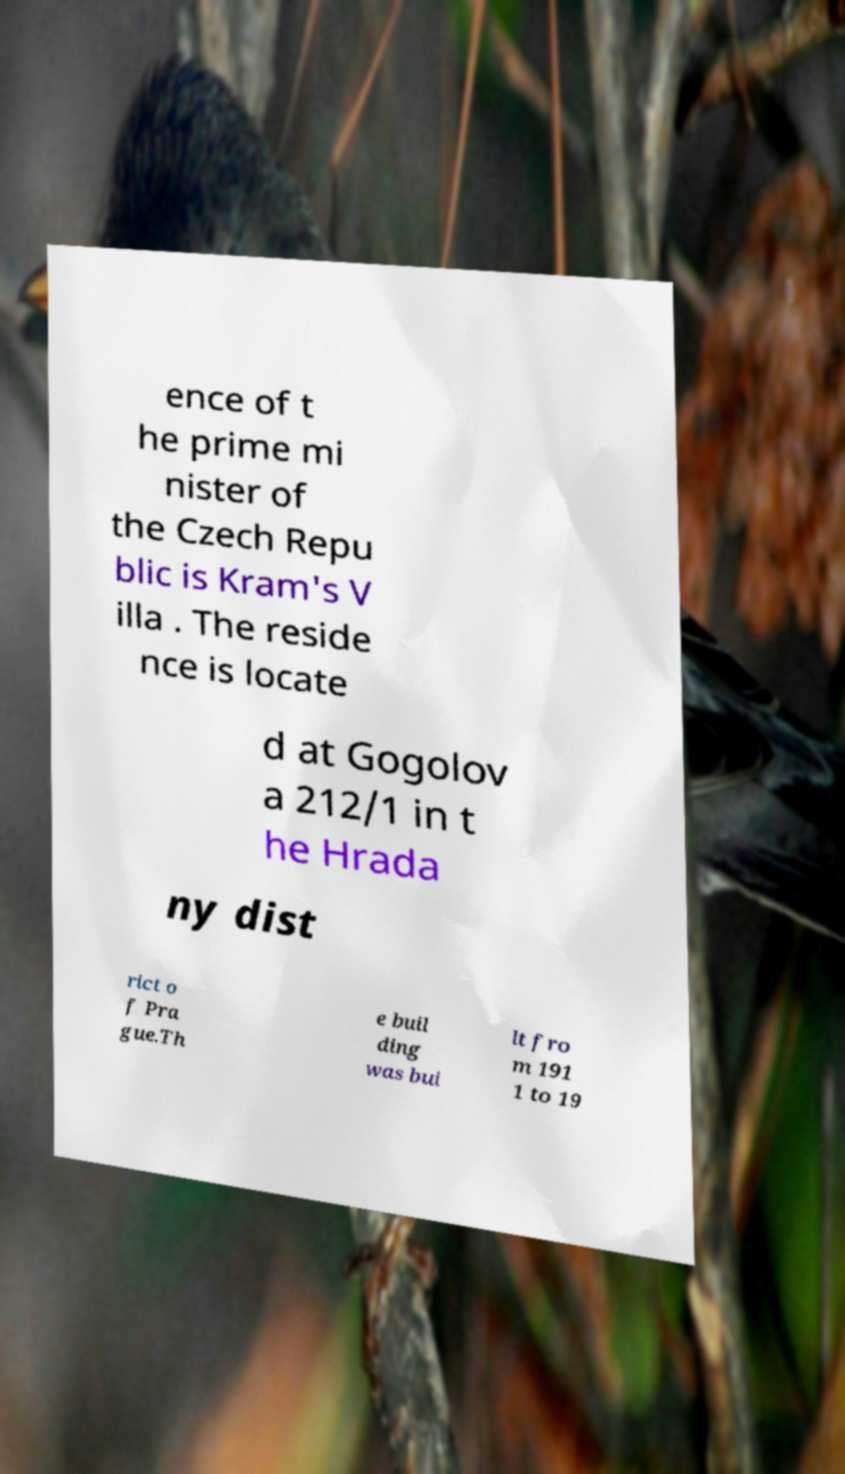Can you read and provide the text displayed in the image?This photo seems to have some interesting text. Can you extract and type it out for me? ence of t he prime mi nister of the Czech Repu blic is Kram's V illa . The reside nce is locate d at Gogolov a 212/1 in t he Hrada ny dist rict o f Pra gue.Th e buil ding was bui lt fro m 191 1 to 19 